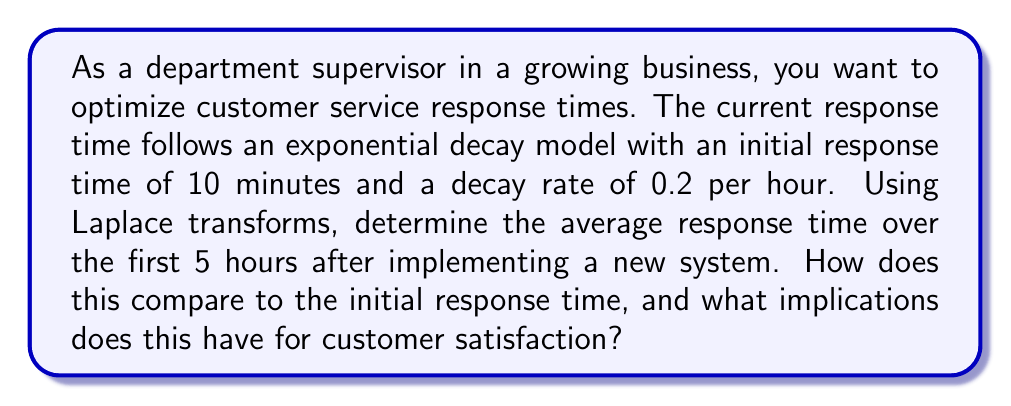Show me your answer to this math problem. Let's approach this step-by-step using Laplace transforms:

1) The response time function can be modeled as:
   $$f(t) = 10e^{-0.2t}$$
   where $t$ is in hours and $f(t)$ is in minutes.

2) The Laplace transform of $f(t)$ is:
   $$F(s) = \mathcal{L}\{f(t)\} = \int_0^\infty 10e^{-0.2t}e^{-st}dt = \frac{10}{s+0.2}$$

3) To find the average response time over the first 5 hours, we need to calculate:
   $$\frac{1}{5}\int_0^5 f(t)dt$$

4) We can use the Laplace transform to solve this integral. First, let's find the Laplace transform of the integral:
   $$\mathcal{L}\{\int_0^t f(\tau)d\tau\} = \frac{F(s)}{s} = \frac{10}{s(s+0.2)}$$

5) Now, we need to find the inverse Laplace transform of this function:
   $$\mathcal{L}^{-1}\{\frac{10}{s(s+0.2)}\} = 10\left(\frac{1}{0.2} - \frac{1}{0.2}e^{-0.2t}\right) = 50(1-e^{-0.2t})$$

6) Evaluating this at $t=5$ and dividing by 5 gives us the average response time:
   $$\frac{1}{5}[50(1-e^{-0.2(5)})] = 10(1-e^{-1}) \approx 6.32\text{ minutes}$$

7) Comparing this to the initial response time of 10 minutes:
   $$\text{Improvement} = 10 - 6.32 = 3.68\text{ minutes}$$
   $$\text{Percentage improvement} = \frac{3.68}{10} \times 100\% = 36.8\%$$

This significant improvement in average response time over the first 5 hours implies a potential increase in customer satisfaction. Customers are likely to experience shorter wait times, leading to more positive interactions with the company.
Answer: The average response time over the first 5 hours is approximately 6.32 minutes, which is a 36.8% improvement from the initial response time of 10 minutes. This substantial reduction in average wait time suggests a likely increase in customer satisfaction. 